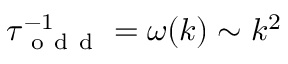Convert formula to latex. <formula><loc_0><loc_0><loc_500><loc_500>\tau _ { o d d } ^ { - 1 } = \omega ( k ) \sim k ^ { 2 }</formula> 